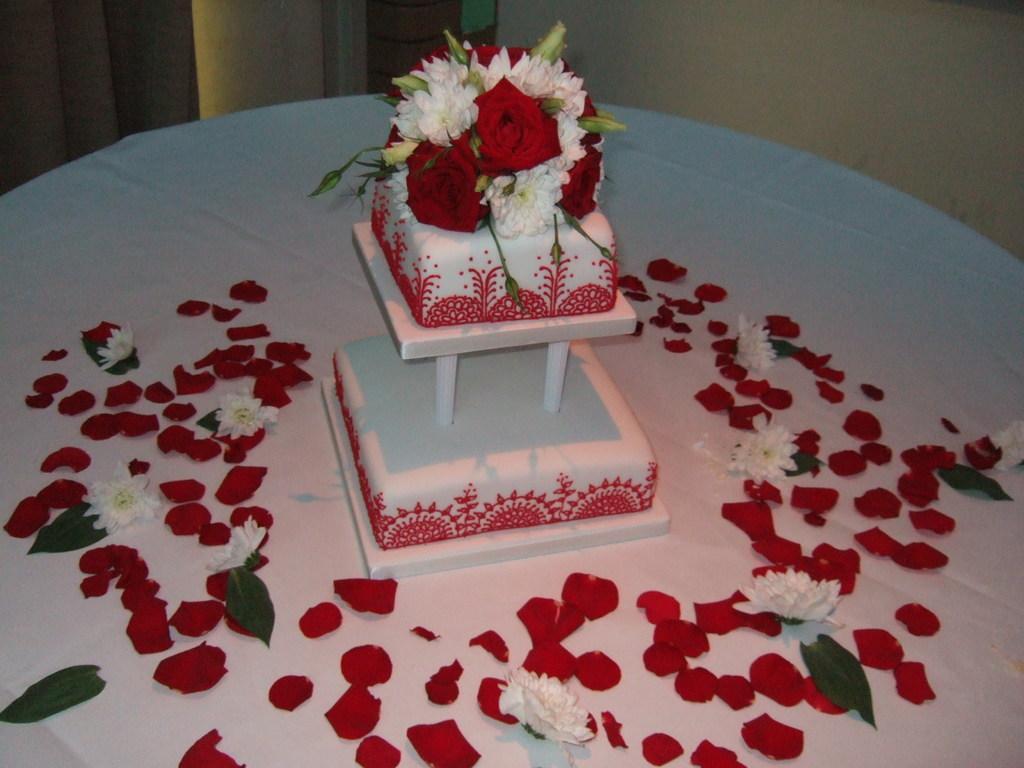How would you summarize this image in a sentence or two? In this image we can see a cake on a white cloth. Beside the cake we can see petals, flowers and leaves. At the top we can see the wall. 